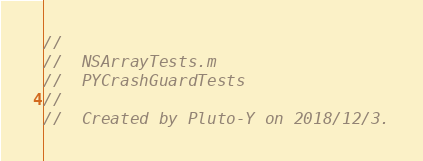Convert code to text. <code><loc_0><loc_0><loc_500><loc_500><_ObjectiveC_>//
//  NSArrayTests.m
//  PYCrashGuardTests
//
//  Created by Pluto-Y on 2018/12/3.</code> 